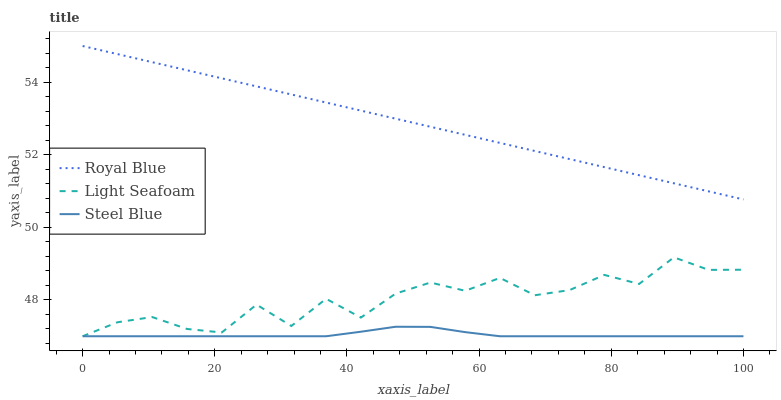Does Steel Blue have the minimum area under the curve?
Answer yes or no. Yes. Does Royal Blue have the maximum area under the curve?
Answer yes or no. Yes. Does Light Seafoam have the minimum area under the curve?
Answer yes or no. No. Does Light Seafoam have the maximum area under the curve?
Answer yes or no. No. Is Royal Blue the smoothest?
Answer yes or no. Yes. Is Light Seafoam the roughest?
Answer yes or no. Yes. Is Steel Blue the smoothest?
Answer yes or no. No. Is Steel Blue the roughest?
Answer yes or no. No. Does Light Seafoam have the highest value?
Answer yes or no. No. Is Light Seafoam less than Royal Blue?
Answer yes or no. Yes. Is Royal Blue greater than Steel Blue?
Answer yes or no. Yes. Does Light Seafoam intersect Royal Blue?
Answer yes or no. No. 